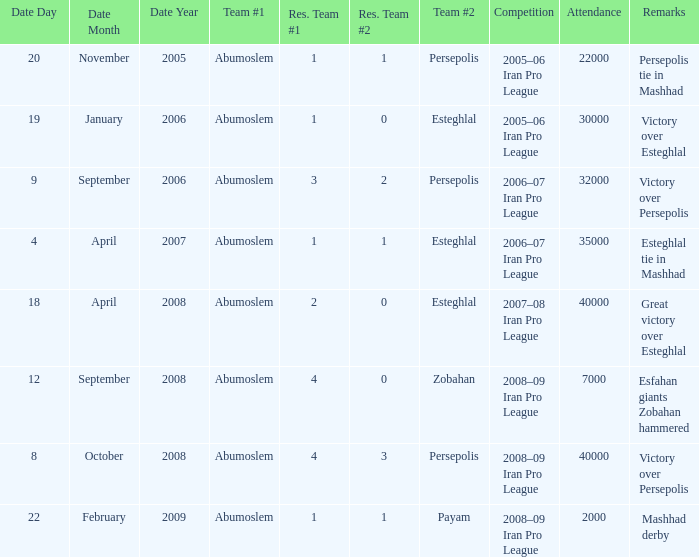Who was team #1 on 9 September 2006? Abumoslem. 